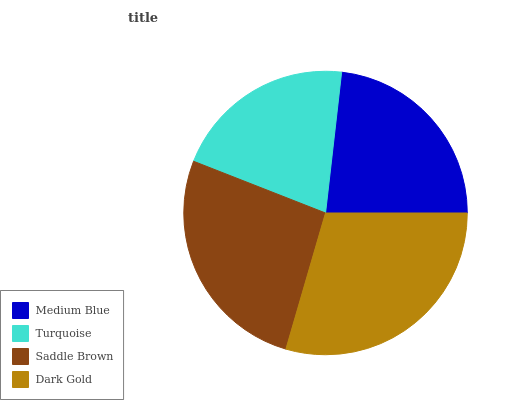Is Turquoise the minimum?
Answer yes or no. Yes. Is Dark Gold the maximum?
Answer yes or no. Yes. Is Saddle Brown the minimum?
Answer yes or no. No. Is Saddle Brown the maximum?
Answer yes or no. No. Is Saddle Brown greater than Turquoise?
Answer yes or no. Yes. Is Turquoise less than Saddle Brown?
Answer yes or no. Yes. Is Turquoise greater than Saddle Brown?
Answer yes or no. No. Is Saddle Brown less than Turquoise?
Answer yes or no. No. Is Saddle Brown the high median?
Answer yes or no. Yes. Is Medium Blue the low median?
Answer yes or no. Yes. Is Medium Blue the high median?
Answer yes or no. No. Is Turquoise the low median?
Answer yes or no. No. 